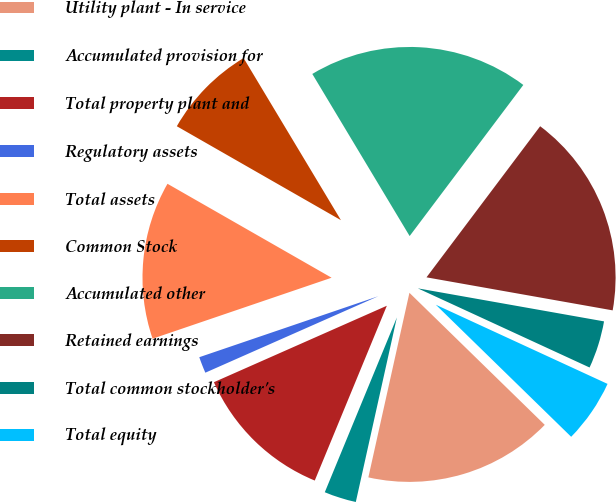<chart> <loc_0><loc_0><loc_500><loc_500><pie_chart><fcel>Utility plant - In service<fcel>Accumulated provision for<fcel>Total property plant and<fcel>Regulatory assets<fcel>Total assets<fcel>Common Stock<fcel>Accumulated other<fcel>Retained earnings<fcel>Total common stockholder's<fcel>Total equity<nl><fcel>16.18%<fcel>2.74%<fcel>12.15%<fcel>1.4%<fcel>13.5%<fcel>8.12%<fcel>18.87%<fcel>17.53%<fcel>4.08%<fcel>5.43%<nl></chart> 